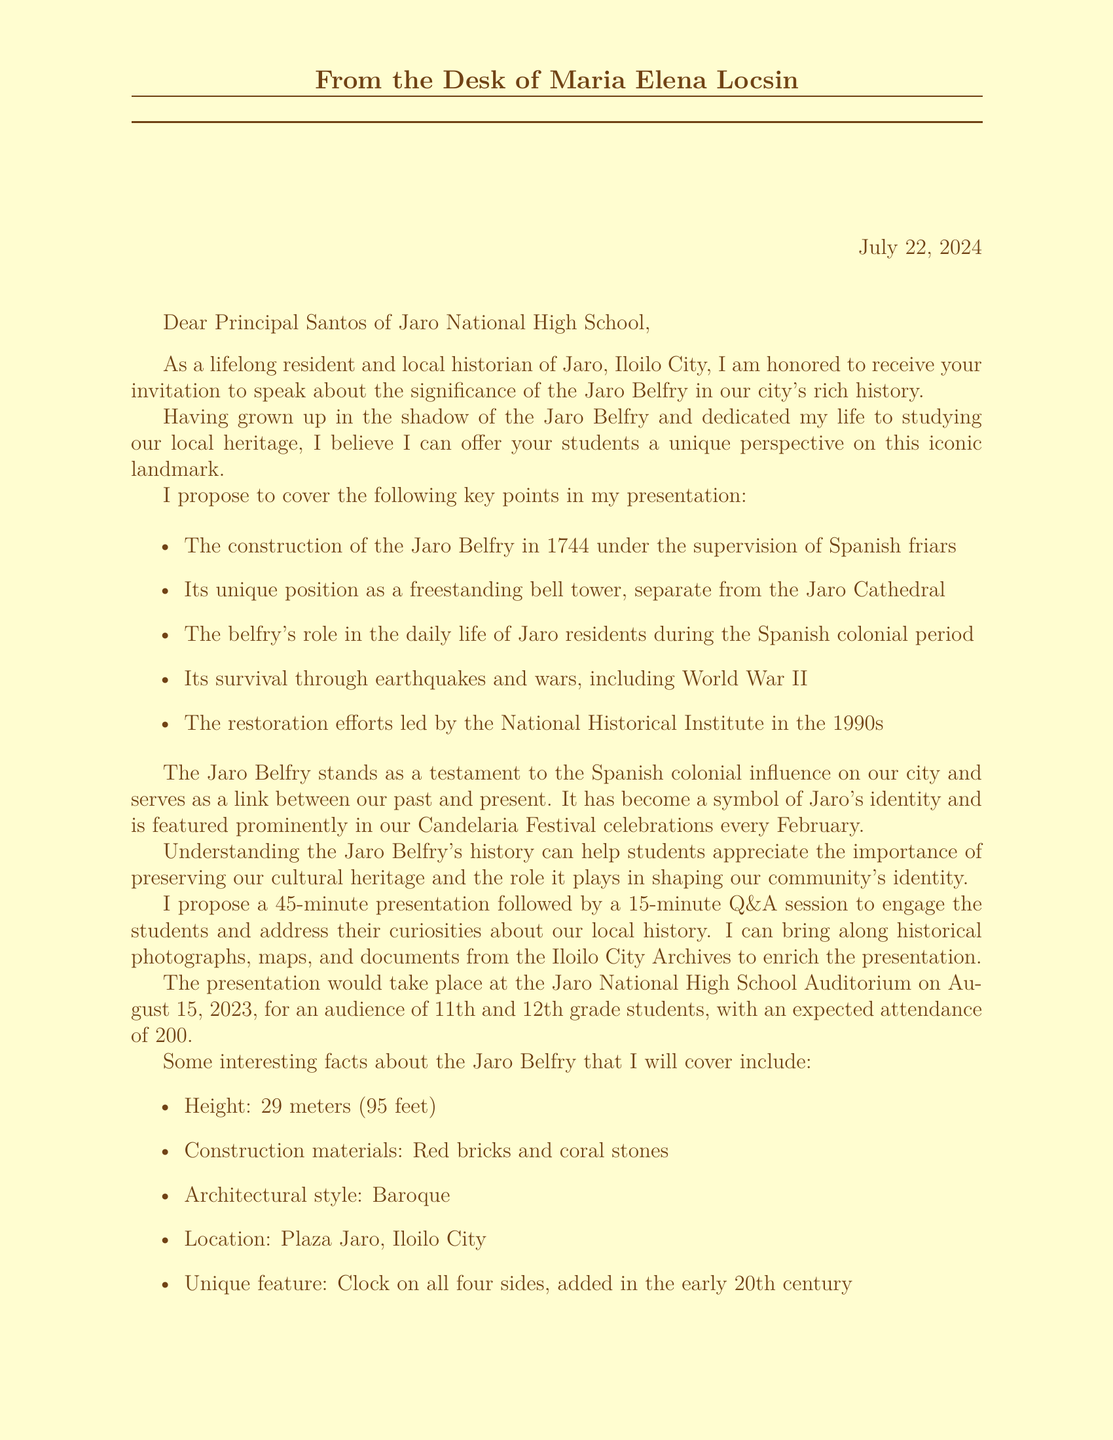What is the name of the speaker? The document specifies the speaker's name at the end in the signature section.
Answer: Maria Elena Locsin What is the proposed date for the presentation? The document clearly states the proposed date in the event details section.
Answer: August 15, 2023 How long is the proposed presentation? The length of the proposed presentation is mentioned in the educational value section of the document.
Answer: 45 minutes What is the height of the Jaro Belfry? The document provides specific facts about the Jaro Belfry, including its height.
Answer: 29 meters (95 feet) What unique feature does the Jaro Belfry have? The document discusses specific features of the Jaro Belfry, including its unique aspect.
Answer: Clock on all four sides, added in the early 20th century What is the cultural significance of the Jaro Belfry? This information is in the cultural significance section of the document, which highlights its role in local celebrations.
Answer: A symbol of Jaro's identity What is the audience for the presentation? The target audience is stated in the event details of the document.
Answer: 11th and 12th grade students What type of materials will the speaker bring to the presentation? The speaker mentions specific resources they can bring in the additional resources section of the document.
Answer: Historical photographs, maps, and documents Who supervised the construction of the Jaro Belfry? The construction details in the topic highlights section mention who was responsible for overseeing it.
Answer: Spanish friars What is the architectural style of the Jaro Belfry? The document explicitly describes the architectural style of the Jaro Belfry as part of the facts.
Answer: Baroque 